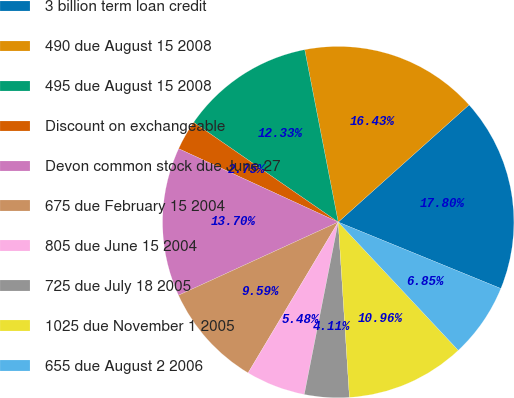<chart> <loc_0><loc_0><loc_500><loc_500><pie_chart><fcel>3 billion term loan credit<fcel>490 due August 15 2008<fcel>495 due August 15 2008<fcel>Discount on exchangeable<fcel>Devon common stock due June 27<fcel>675 due February 15 2004<fcel>805 due June 15 2004<fcel>725 due July 18 2005<fcel>1025 due November 1 2005<fcel>655 due August 2 2006<nl><fcel>17.8%<fcel>16.43%<fcel>12.33%<fcel>2.75%<fcel>13.7%<fcel>9.59%<fcel>5.48%<fcel>4.11%<fcel>10.96%<fcel>6.85%<nl></chart> 